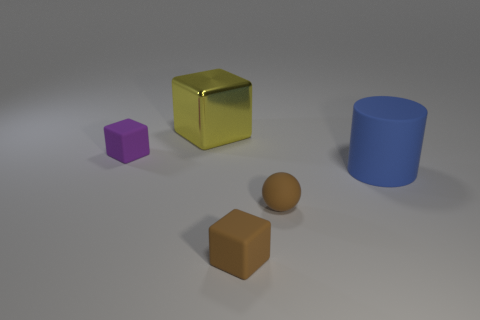What is the shape of the thing that is the same color as the tiny rubber sphere? The object sharing the same color as the small rubber sphere is a cube. It's a gold-colored cube with a reflective surface, visually distinct from the other objects due to its vibrant hue and sharp edges. 